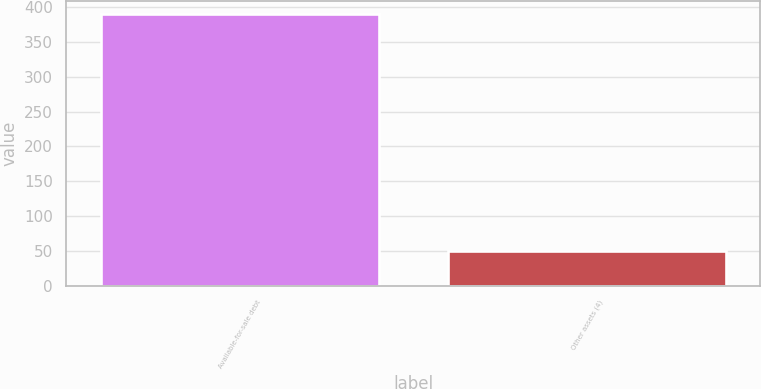<chart> <loc_0><loc_0><loc_500><loc_500><bar_chart><fcel>Available-for-sale debt<fcel>Other assets (4)<nl><fcel>390<fcel>50<nl></chart> 